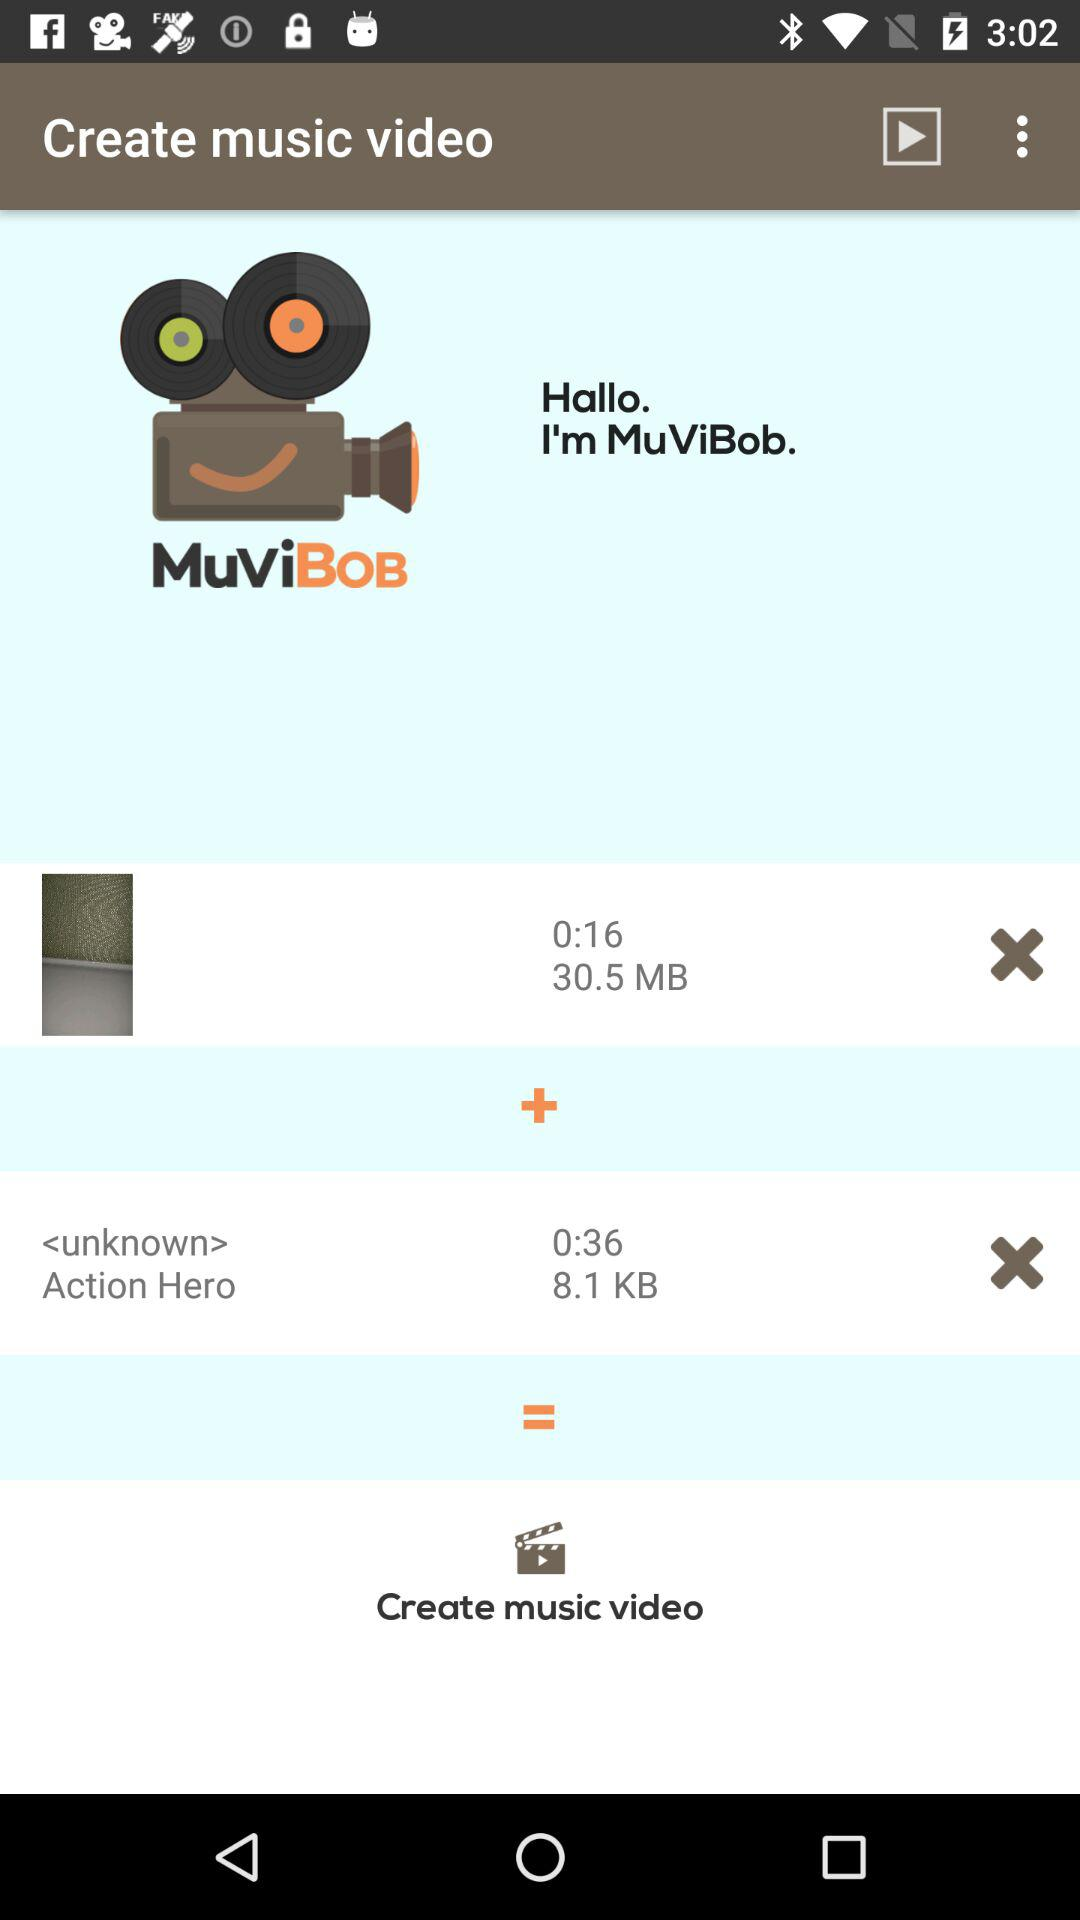How many video clips does the user have?
Answer the question using a single word or phrase. 2 